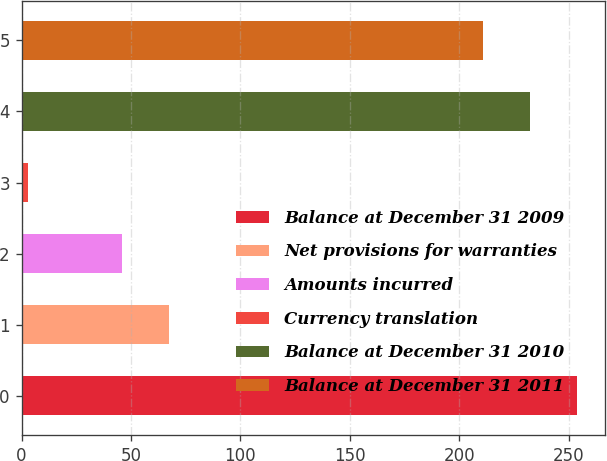<chart> <loc_0><loc_0><loc_500><loc_500><bar_chart><fcel>Balance at December 31 2009<fcel>Net provisions for warranties<fcel>Amounts incurred<fcel>Currency translation<fcel>Balance at December 31 2010<fcel>Balance at December 31 2011<nl><fcel>253.8<fcel>67.2<fcel>45.8<fcel>3<fcel>232.4<fcel>211<nl></chart> 